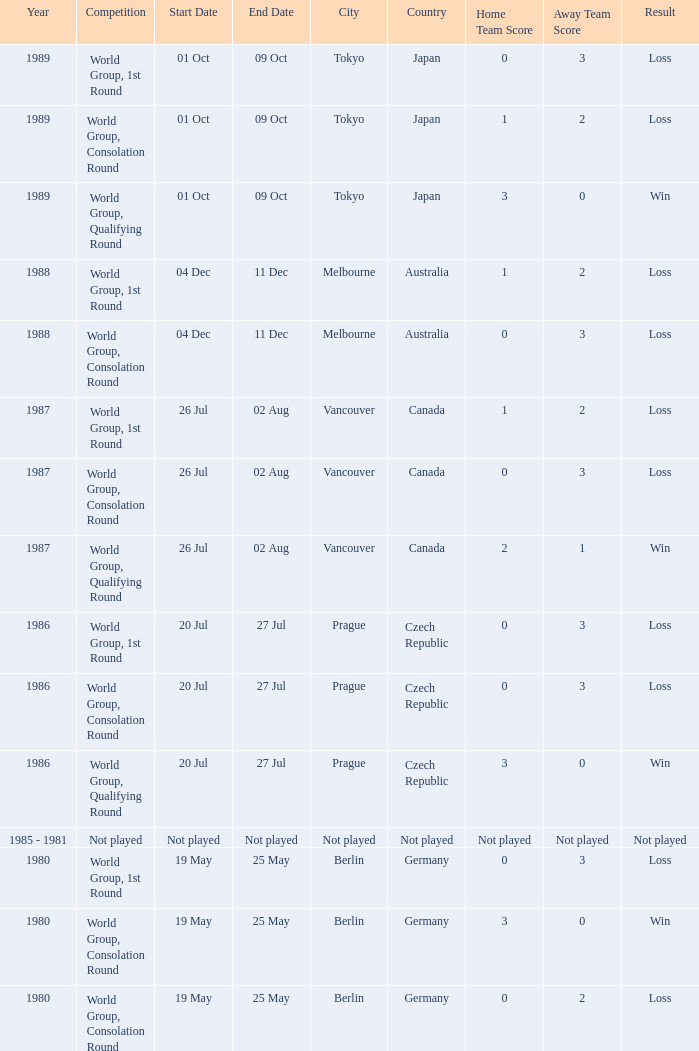What is the score when the result is loss, the year is 1980 and the competition is world group, consolation round? 0-2. 